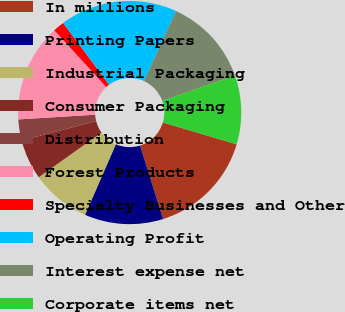<chart> <loc_0><loc_0><loc_500><loc_500><pie_chart><fcel>In millions<fcel>Printing Papers<fcel>Industrial Packaging<fcel>Consumer Packaging<fcel>Distribution<fcel>Forest Products<fcel>Specialty Businesses and Other<fcel>Operating Profit<fcel>Interest expense net<fcel>Corporate items net<nl><fcel>15.57%<fcel>11.39%<fcel>8.61%<fcel>5.82%<fcel>3.04%<fcel>14.18%<fcel>1.64%<fcel>16.96%<fcel>12.79%<fcel>10.0%<nl></chart> 